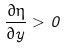<formula> <loc_0><loc_0><loc_500><loc_500>\frac { \partial \eta } { \partial y } > 0</formula> 